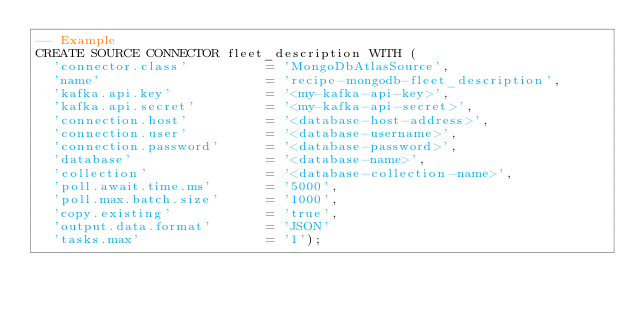Convert code to text. <code><loc_0><loc_0><loc_500><loc_500><_SQL_>-- Example
CREATE SOURCE CONNECTOR fleet_description WITH (
  'connector.class'          = 'MongoDbAtlasSource',
  'name'                     = 'recipe-mongodb-fleet_description',
  'kafka.api.key'            = '<my-kafka-api-key>',
  'kafka.api.secret'         = '<my-kafka-api-secret>',
  'connection.host'          = '<database-host-address>',
  'connection.user'          = '<database-username>',
  'connection.password'      = '<database-password>',
  'database'                 = '<database-name>',
  'collection'               = '<database-collection-name>',
  'poll.await.time.ms'       = '5000',
  'poll.max.batch.size'      = '1000',
  'copy.existing'            = 'true',
  'output.data.format'       = 'JSON'
  'tasks.max'                = '1');
</code> 